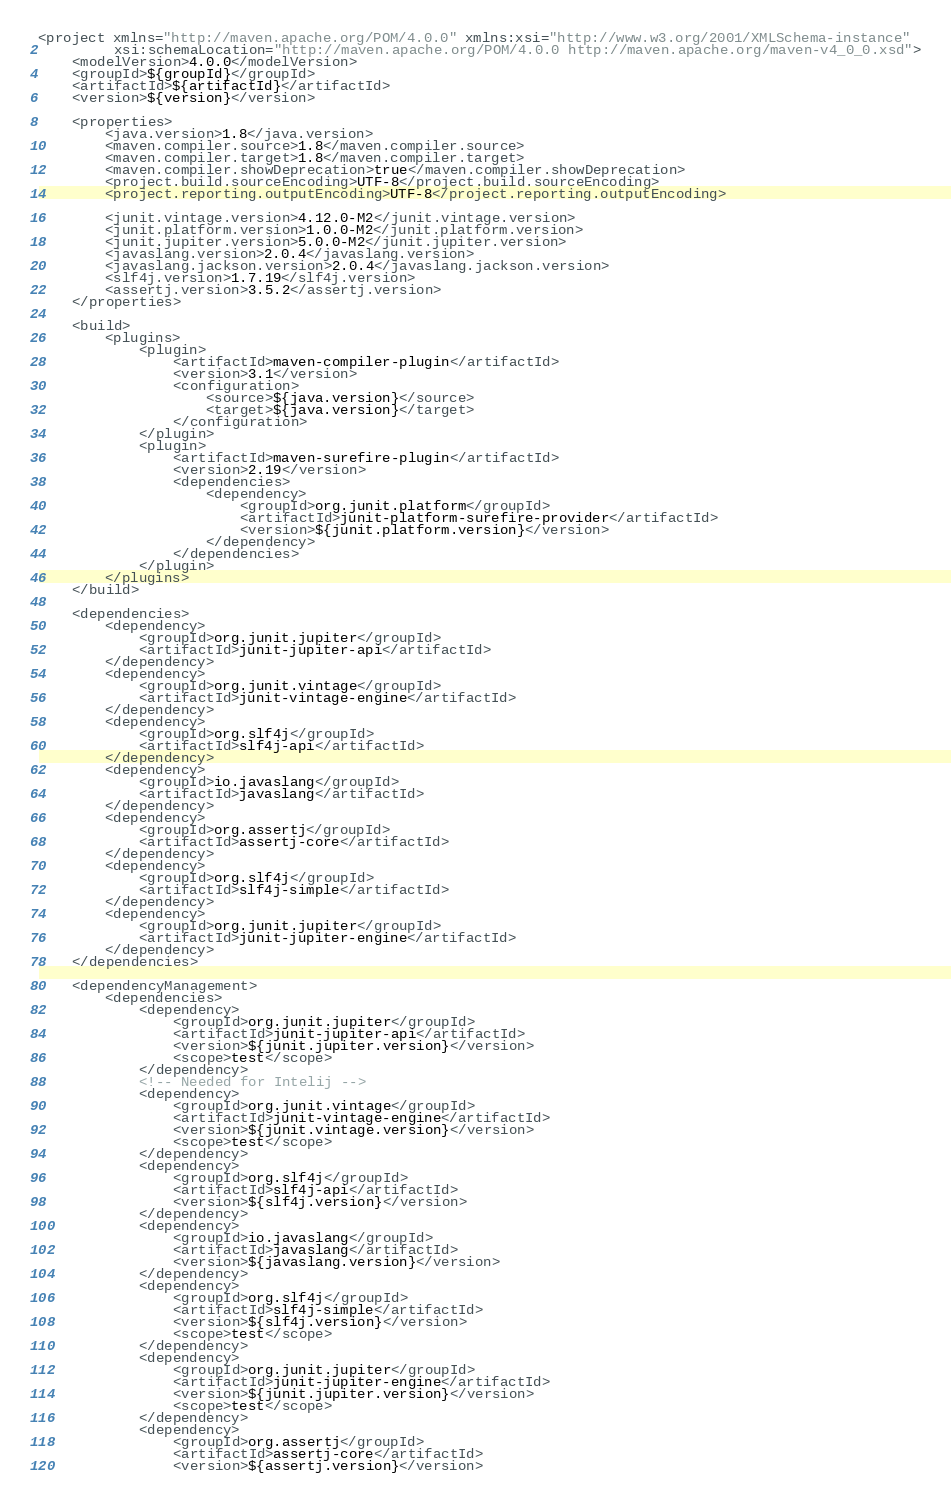Convert code to text. <code><loc_0><loc_0><loc_500><loc_500><_XML_><project xmlns="http://maven.apache.org/POM/4.0.0" xmlns:xsi="http://www.w3.org/2001/XMLSchema-instance"
         xsi:schemaLocation="http://maven.apache.org/POM/4.0.0 http://maven.apache.org/maven-v4_0_0.xsd">
    <modelVersion>4.0.0</modelVersion>
    <groupId>${groupId}</groupId>
    <artifactId>${artifactId}</artifactId>
    <version>${version}</version>

    <properties>
        <java.version>1.8</java.version>
        <maven.compiler.source>1.8</maven.compiler.source>
        <maven.compiler.target>1.8</maven.compiler.target>
        <maven.compiler.showDeprecation>true</maven.compiler.showDeprecation>
        <project.build.sourceEncoding>UTF-8</project.build.sourceEncoding>
        <project.reporting.outputEncoding>UTF-8</project.reporting.outputEncoding>

        <junit.vintage.version>4.12.0-M2</junit.vintage.version>
        <junit.platform.version>1.0.0-M2</junit.platform.version>
        <junit.jupiter.version>5.0.0-M2</junit.jupiter.version>
        <javaslang.version>2.0.4</javaslang.version>
        <javaslang.jackson.version>2.0.4</javaslang.jackson.version>
        <slf4j.version>1.7.19</slf4j.version>
        <assertj.version>3.5.2</assertj.version>
    </properties>

    <build>
        <plugins>
            <plugin>
                <artifactId>maven-compiler-plugin</artifactId>
                <version>3.1</version>
                <configuration>
                    <source>${java.version}</source>
                    <target>${java.version}</target>
                </configuration>
            </plugin>
            <plugin>
                <artifactId>maven-surefire-plugin</artifactId>
                <version>2.19</version>
                <dependencies>
                    <dependency>
                        <groupId>org.junit.platform</groupId>
                        <artifactId>junit-platform-surefire-provider</artifactId>
                        <version>${junit.platform.version}</version>
                    </dependency>
                </dependencies>
            </plugin>
        </plugins>
    </build>

    <dependencies>
        <dependency>
            <groupId>org.junit.jupiter</groupId>
            <artifactId>junit-jupiter-api</artifactId>
        </dependency>
        <dependency>
            <groupId>org.junit.vintage</groupId>
            <artifactId>junit-vintage-engine</artifactId>
        </dependency>
        <dependency>
            <groupId>org.slf4j</groupId>
            <artifactId>slf4j-api</artifactId>
        </dependency>
        <dependency>
            <groupId>io.javaslang</groupId>
            <artifactId>javaslang</artifactId>
        </dependency>
        <dependency>
            <groupId>org.assertj</groupId>
            <artifactId>assertj-core</artifactId>
        </dependency>
        <dependency>
            <groupId>org.slf4j</groupId>
            <artifactId>slf4j-simple</artifactId>
        </dependency>
        <dependency>
            <groupId>org.junit.jupiter</groupId>
            <artifactId>junit-jupiter-engine</artifactId>
        </dependency>
    </dependencies>

    <dependencyManagement>
        <dependencies>
            <dependency>
                <groupId>org.junit.jupiter</groupId>
                <artifactId>junit-jupiter-api</artifactId>
                <version>${junit.jupiter.version}</version>
                <scope>test</scope>
            </dependency>
            <!-- Needed for Intelij -->
            <dependency>
                <groupId>org.junit.vintage</groupId>
                <artifactId>junit-vintage-engine</artifactId>
                <version>${junit.vintage.version}</version>
                <scope>test</scope>
            </dependency>
            <dependency>
                <groupId>org.slf4j</groupId>
                <artifactId>slf4j-api</artifactId>
                <version>${slf4j.version}</version>
            </dependency>
            <dependency>
                <groupId>io.javaslang</groupId>
                <artifactId>javaslang</artifactId>
                <version>${javaslang.version}</version>
            </dependency>
            <dependency>
                <groupId>org.slf4j</groupId>
                <artifactId>slf4j-simple</artifactId>
                <version>${slf4j.version}</version>
                <scope>test</scope>
            </dependency>
            <dependency>
                <groupId>org.junit.jupiter</groupId>
                <artifactId>junit-jupiter-engine</artifactId>
                <version>${junit.jupiter.version}</version>
                <scope>test</scope>
            </dependency>
            <dependency>
                <groupId>org.assertj</groupId>
                <artifactId>assertj-core</artifactId>
                <version>${assertj.version}</version></code> 